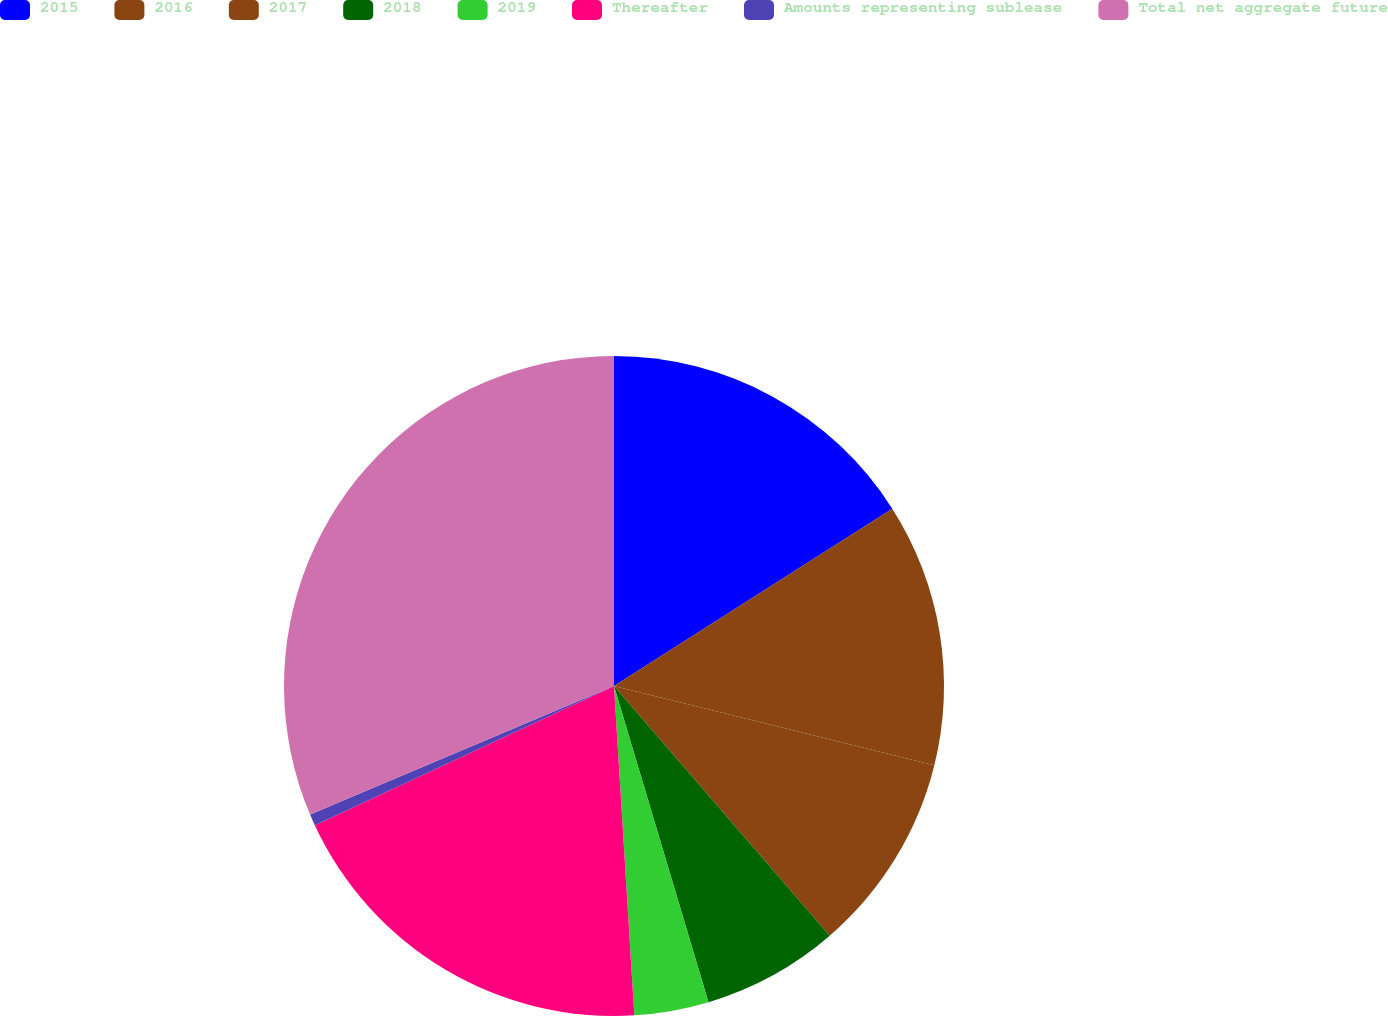Convert chart. <chart><loc_0><loc_0><loc_500><loc_500><pie_chart><fcel>2015<fcel>2016<fcel>2017<fcel>2018<fcel>2019<fcel>Thereafter<fcel>Amounts representing sublease<fcel>Total net aggregate future<nl><fcel>15.97%<fcel>12.89%<fcel>9.8%<fcel>6.72%<fcel>3.64%<fcel>19.05%<fcel>0.56%<fcel>31.37%<nl></chart> 